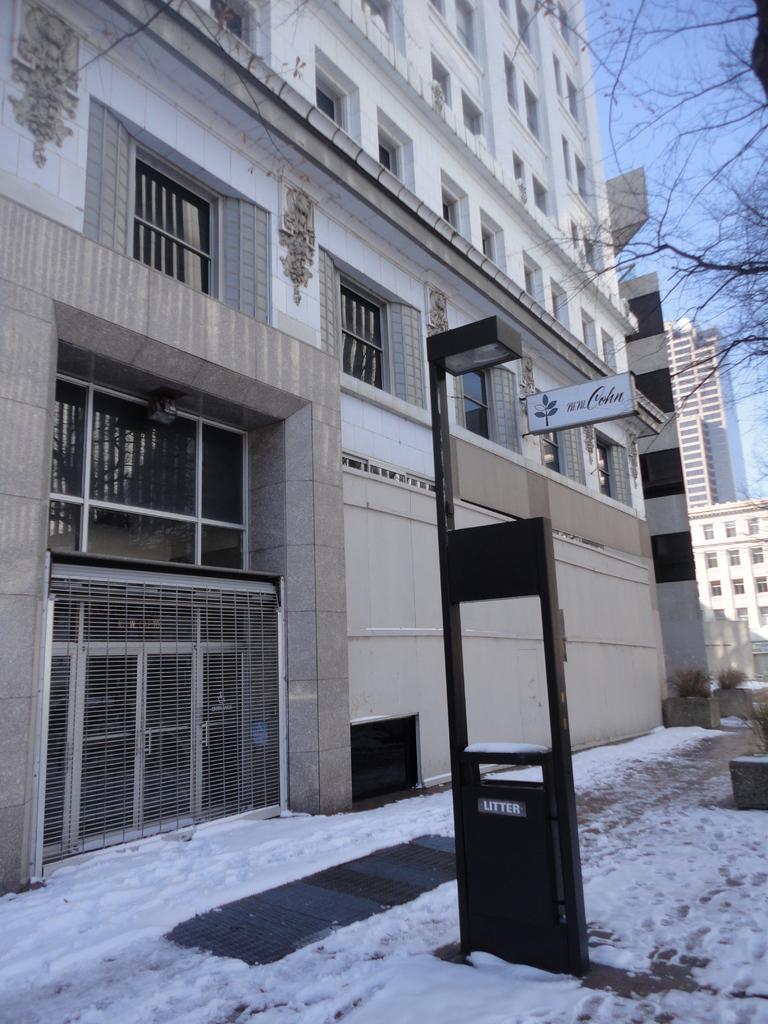Please provide a concise description of this image. In this image we can see buildings and trees. At the bottom of the image we can see snow. In the background there are buildings and sky. 